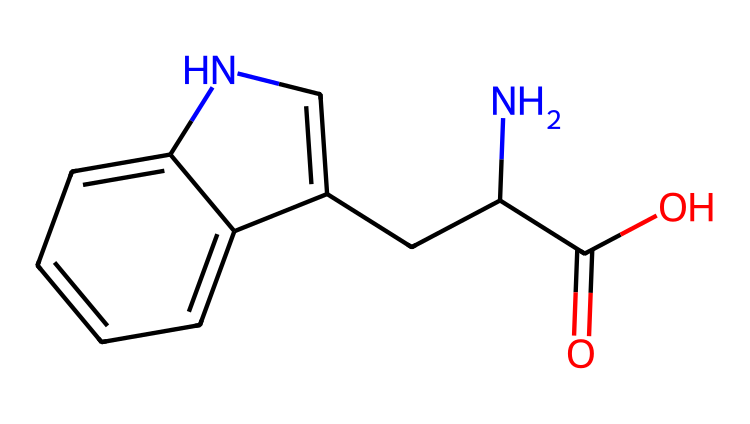What is the functional group indicated by the -COOH in this molecule? The presence of the -COOH group indicates that this molecule contains a carboxylic acid functional group, which consists of a carbonyl (C=O) and a hydroxyl (-OH) group.
Answer: carboxylic acid How many nitrogen atoms are present in tryptophan? By examining the structure, we can identify that there are two nitrogen atoms present: one in the amine group and another within the indole ring.
Answer: 2 What type of amino acid is tryptophan based on its side chain? The side chain of tryptophan features an indole ring, which is characteristic of aromatic amino acids. Hence, tryptophan is classified as an aromatic amino acid.
Answer: aromatic What is the total number of carbon atoms in tryptophan? Counting all the carbon atoms in the structure leads to a total of 11 carbon atoms: 9 in the main chain and 2 in the indole structure.
Answer: 11 Which part of tryptophan is responsible for its role in serotonin synthesis? The indole ring structure is crucial because it serves as a precursor for serotonin, a neurotransmitter that influences mood and cognition.
Answer: indole ring Does tryptophan have a polar or non-polar side chain? The side chain of tryptophan is largely non-polar due to the presence of the indole ring, which is hydrophobic, although it has some polar characteristics.
Answer: non-polar 